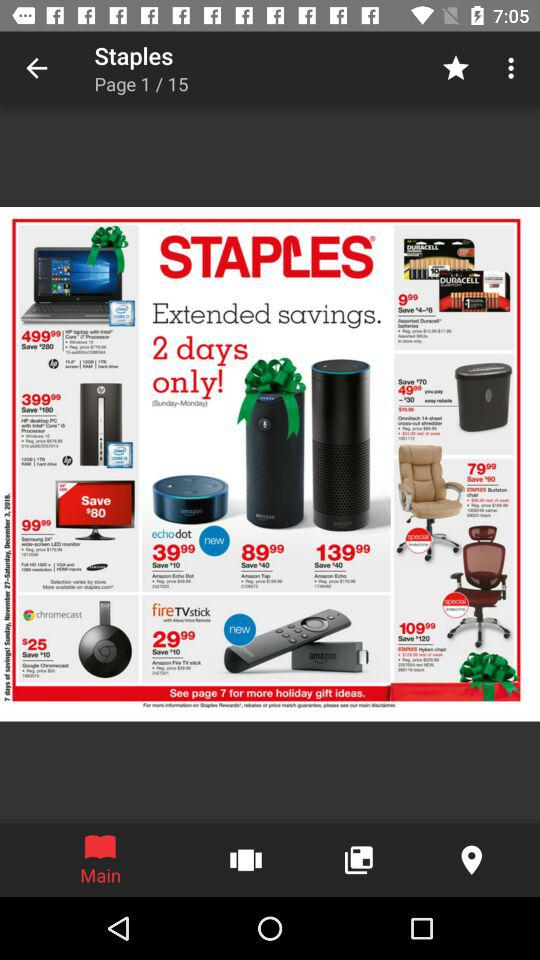How many pages are in the flyer?
Answer the question using a single word or phrase. 15 